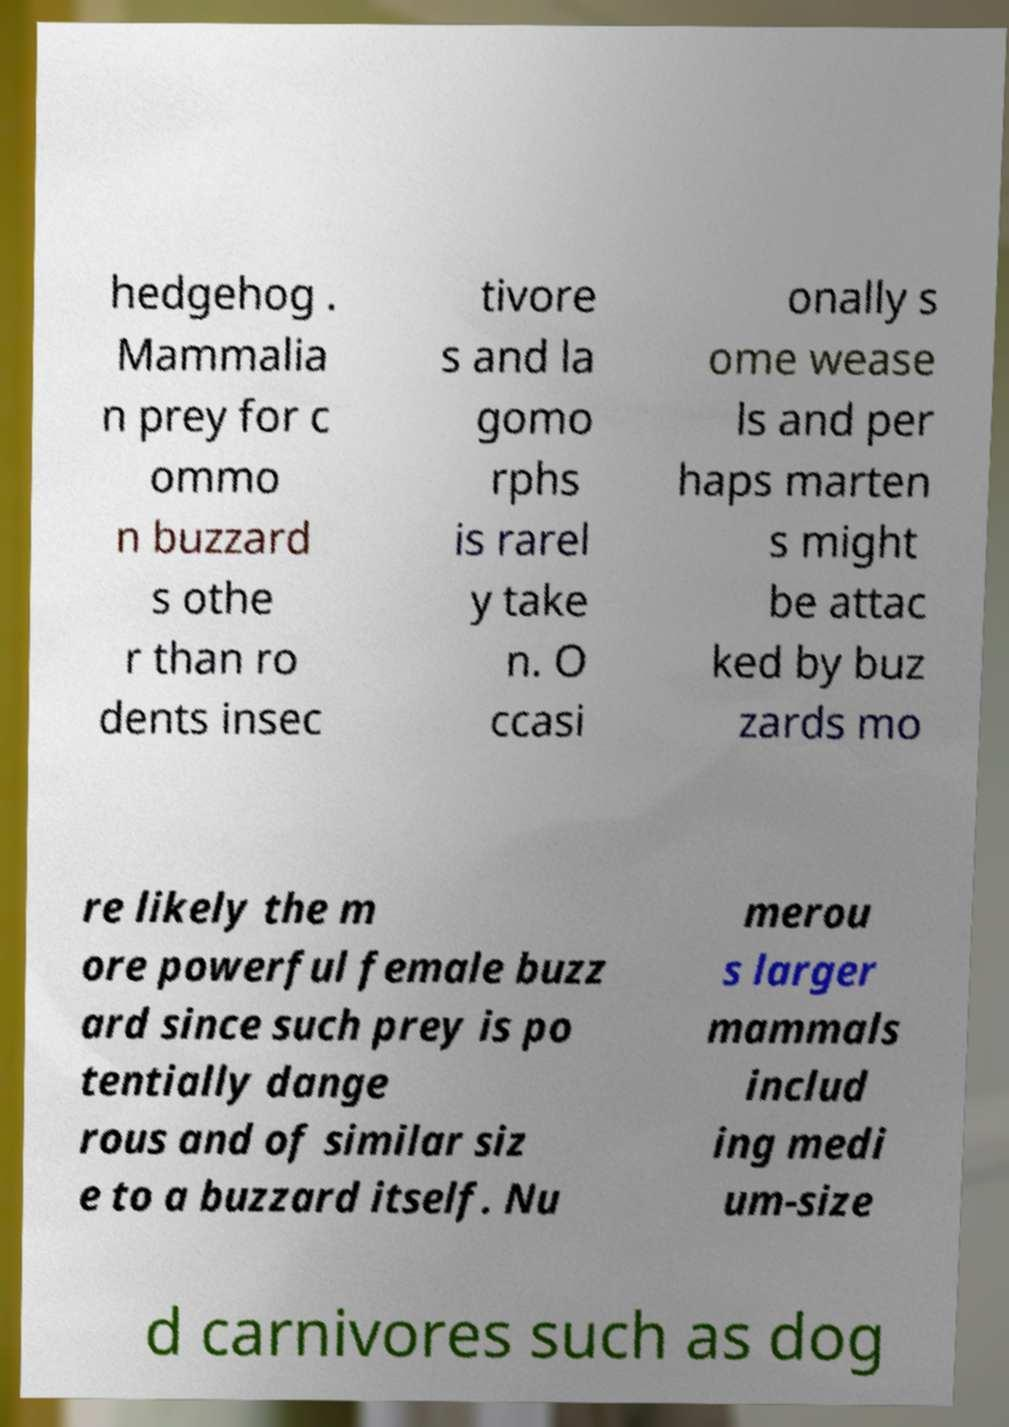Could you assist in decoding the text presented in this image and type it out clearly? hedgehog . Mammalia n prey for c ommo n buzzard s othe r than ro dents insec tivore s and la gomo rphs is rarel y take n. O ccasi onally s ome wease ls and per haps marten s might be attac ked by buz zards mo re likely the m ore powerful female buzz ard since such prey is po tentially dange rous and of similar siz e to a buzzard itself. Nu merou s larger mammals includ ing medi um-size d carnivores such as dog 